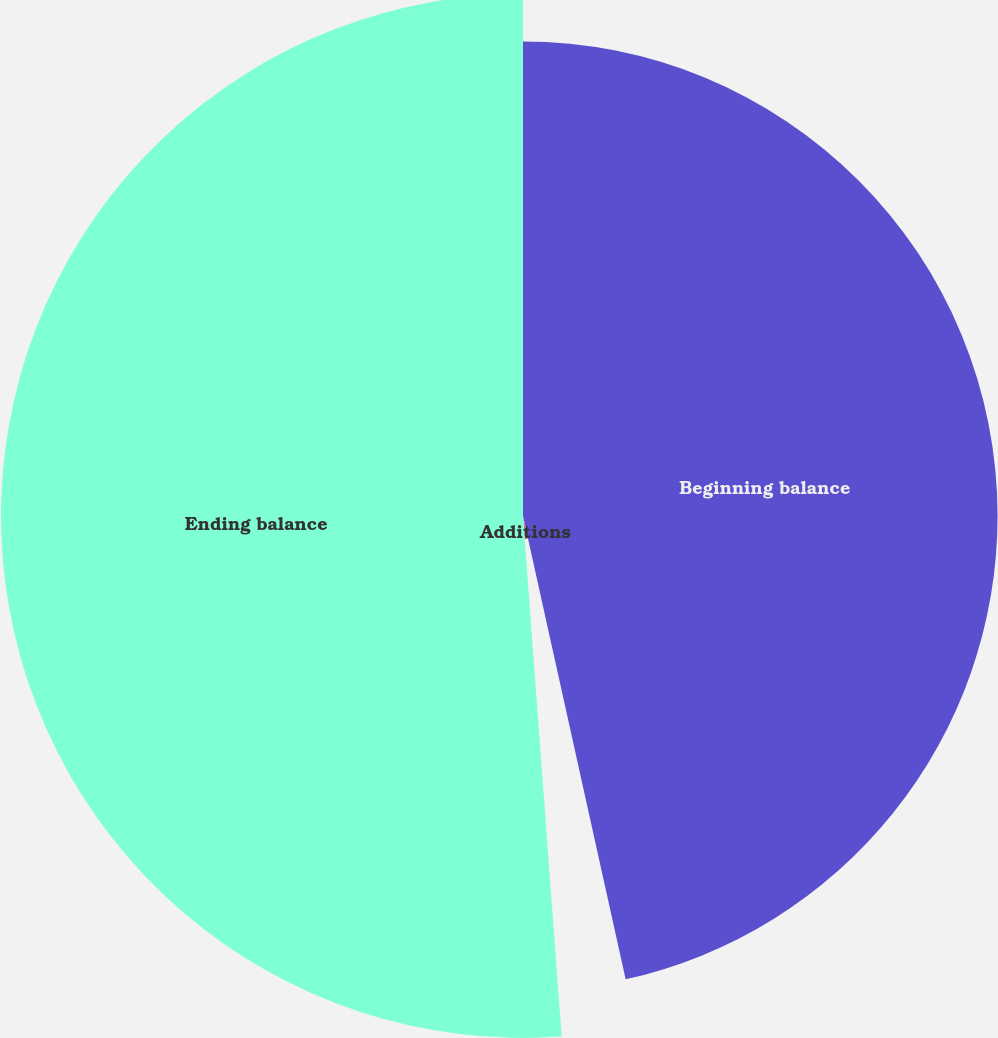<chart> <loc_0><loc_0><loc_500><loc_500><pie_chart><fcel>Beginning balance<fcel>Additions<fcel>Ending balance<nl><fcel>46.53%<fcel>2.29%<fcel>51.18%<nl></chart> 